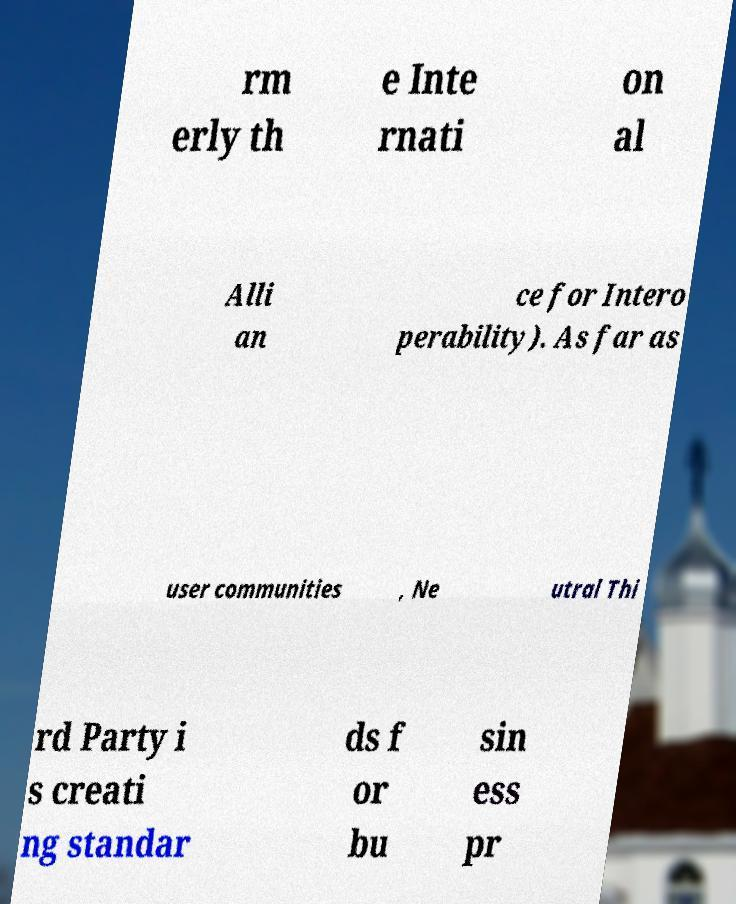There's text embedded in this image that I need extracted. Can you transcribe it verbatim? rm erly th e Inte rnati on al Alli an ce for Intero perability). As far as user communities , Ne utral Thi rd Party i s creati ng standar ds f or bu sin ess pr 